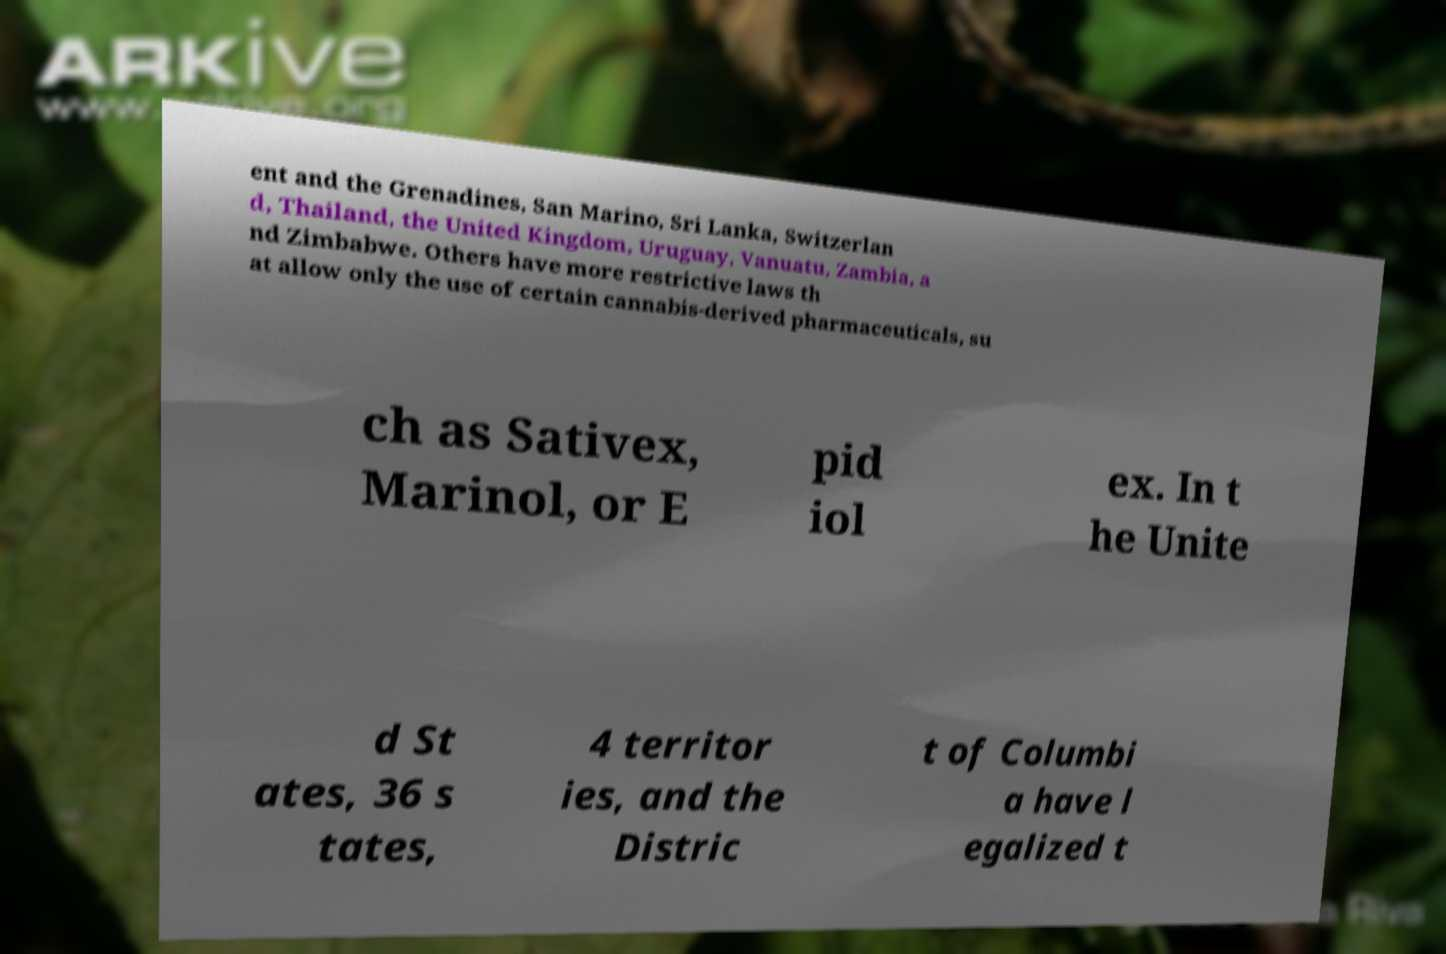Can you read and provide the text displayed in the image?This photo seems to have some interesting text. Can you extract and type it out for me? ent and the Grenadines, San Marino, Sri Lanka, Switzerlan d, Thailand, the United Kingdom, Uruguay, Vanuatu, Zambia, a nd Zimbabwe. Others have more restrictive laws th at allow only the use of certain cannabis-derived pharmaceuticals, su ch as Sativex, Marinol, or E pid iol ex. In t he Unite d St ates, 36 s tates, 4 territor ies, and the Distric t of Columbi a have l egalized t 